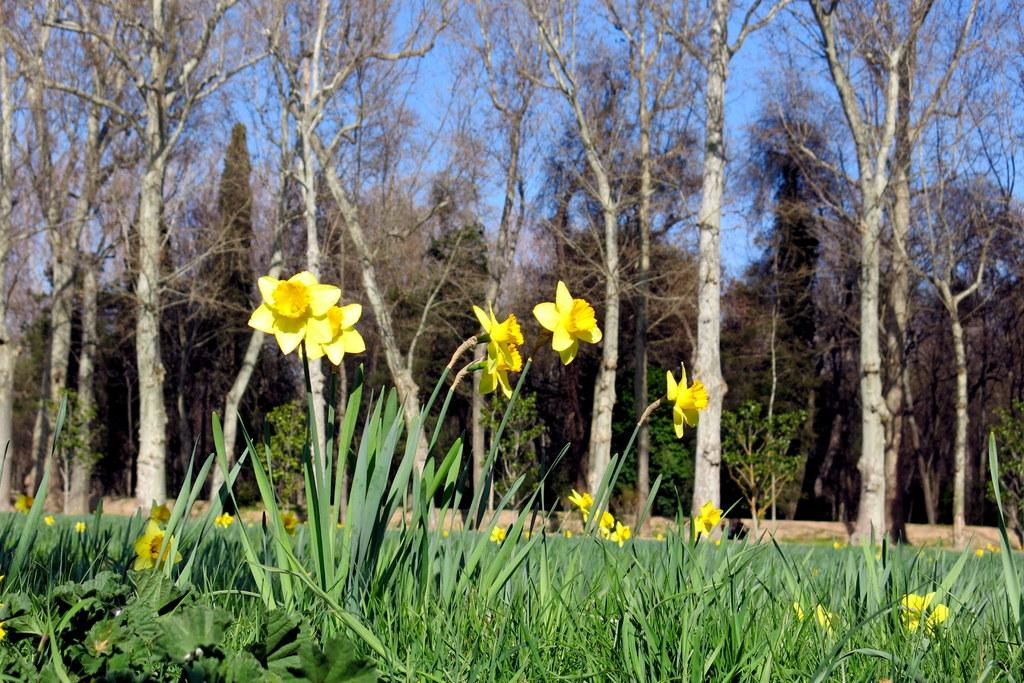What types of vegetation can be seen in the image? There are plants and flowers in the image. What can be seen in the background of the image? There are trees and the sky visible in the background of the image. What is the color of the sky in the image? The color of the sky is blue. What is the opinion of the flowers about the reward system in the image? There are no opinions or rewards present in the image, as it features plants, flowers, trees, and the sky. 